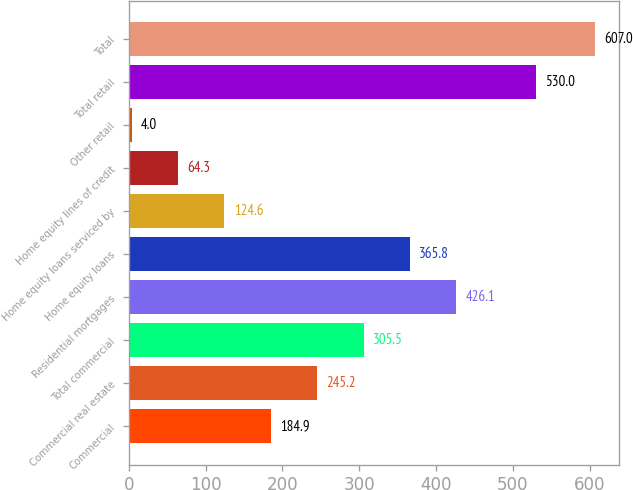Convert chart. <chart><loc_0><loc_0><loc_500><loc_500><bar_chart><fcel>Commercial<fcel>Commercial real estate<fcel>Total commercial<fcel>Residential mortgages<fcel>Home equity loans<fcel>Home equity loans serviced by<fcel>Home equity lines of credit<fcel>Other retail<fcel>Total retail<fcel>Total<nl><fcel>184.9<fcel>245.2<fcel>305.5<fcel>426.1<fcel>365.8<fcel>124.6<fcel>64.3<fcel>4<fcel>530<fcel>607<nl></chart> 